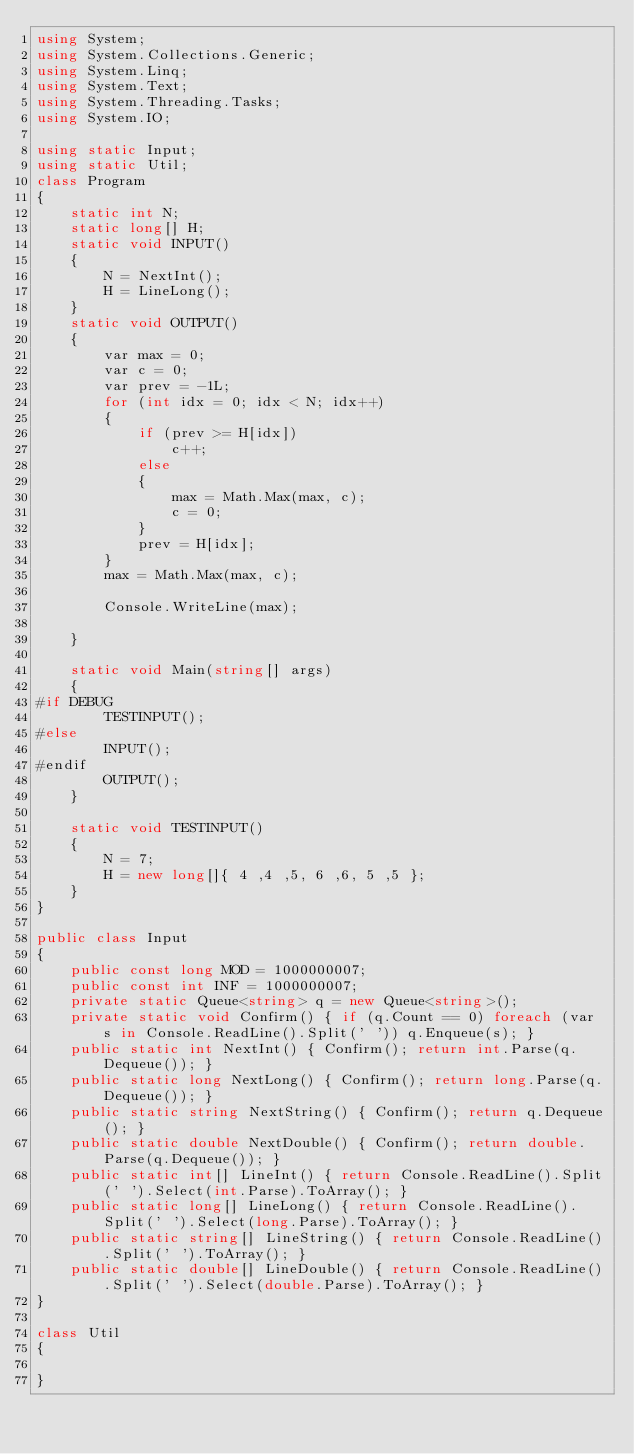Convert code to text. <code><loc_0><loc_0><loc_500><loc_500><_C#_>using System;
using System.Collections.Generic;
using System.Linq;
using System.Text;
using System.Threading.Tasks;
using System.IO;

using static Input;
using static Util;
class Program
{
    static int N;
    static long[] H;
    static void INPUT()
    {
        N = NextInt();
        H = LineLong();
    }
    static void OUTPUT()
    {
        var max = 0;
        var c = 0;
        var prev = -1L;
        for (int idx = 0; idx < N; idx++)
        {
            if (prev >= H[idx])
                c++;
            else
            {
                max = Math.Max(max, c);
                c = 0;
            }
            prev = H[idx];
        }
        max = Math.Max(max, c);

        Console.WriteLine(max);

    }

    static void Main(string[] args)
    {
#if DEBUG  
        TESTINPUT();
#else
        INPUT();
#endif
        OUTPUT();
    }

    static void TESTINPUT()
    {
        N = 7;
        H = new long[]{ 4 ,4 ,5, 6 ,6, 5 ,5 };
    }
}

public class Input
{
    public const long MOD = 1000000007;
    public const int INF = 1000000007;
    private static Queue<string> q = new Queue<string>();
    private static void Confirm() { if (q.Count == 0) foreach (var s in Console.ReadLine().Split(' ')) q.Enqueue(s); }
    public static int NextInt() { Confirm(); return int.Parse(q.Dequeue()); }
    public static long NextLong() { Confirm(); return long.Parse(q.Dequeue()); }
    public static string NextString() { Confirm(); return q.Dequeue(); }
    public static double NextDouble() { Confirm(); return double.Parse(q.Dequeue()); }
    public static int[] LineInt() { return Console.ReadLine().Split(' ').Select(int.Parse).ToArray(); }
    public static long[] LineLong() { return Console.ReadLine().Split(' ').Select(long.Parse).ToArray(); }
    public static string[] LineString() { return Console.ReadLine().Split(' ').ToArray(); }
    public static double[] LineDouble() { return Console.ReadLine().Split(' ').Select(double.Parse).ToArray(); }
}

class Util
{

}


</code> 